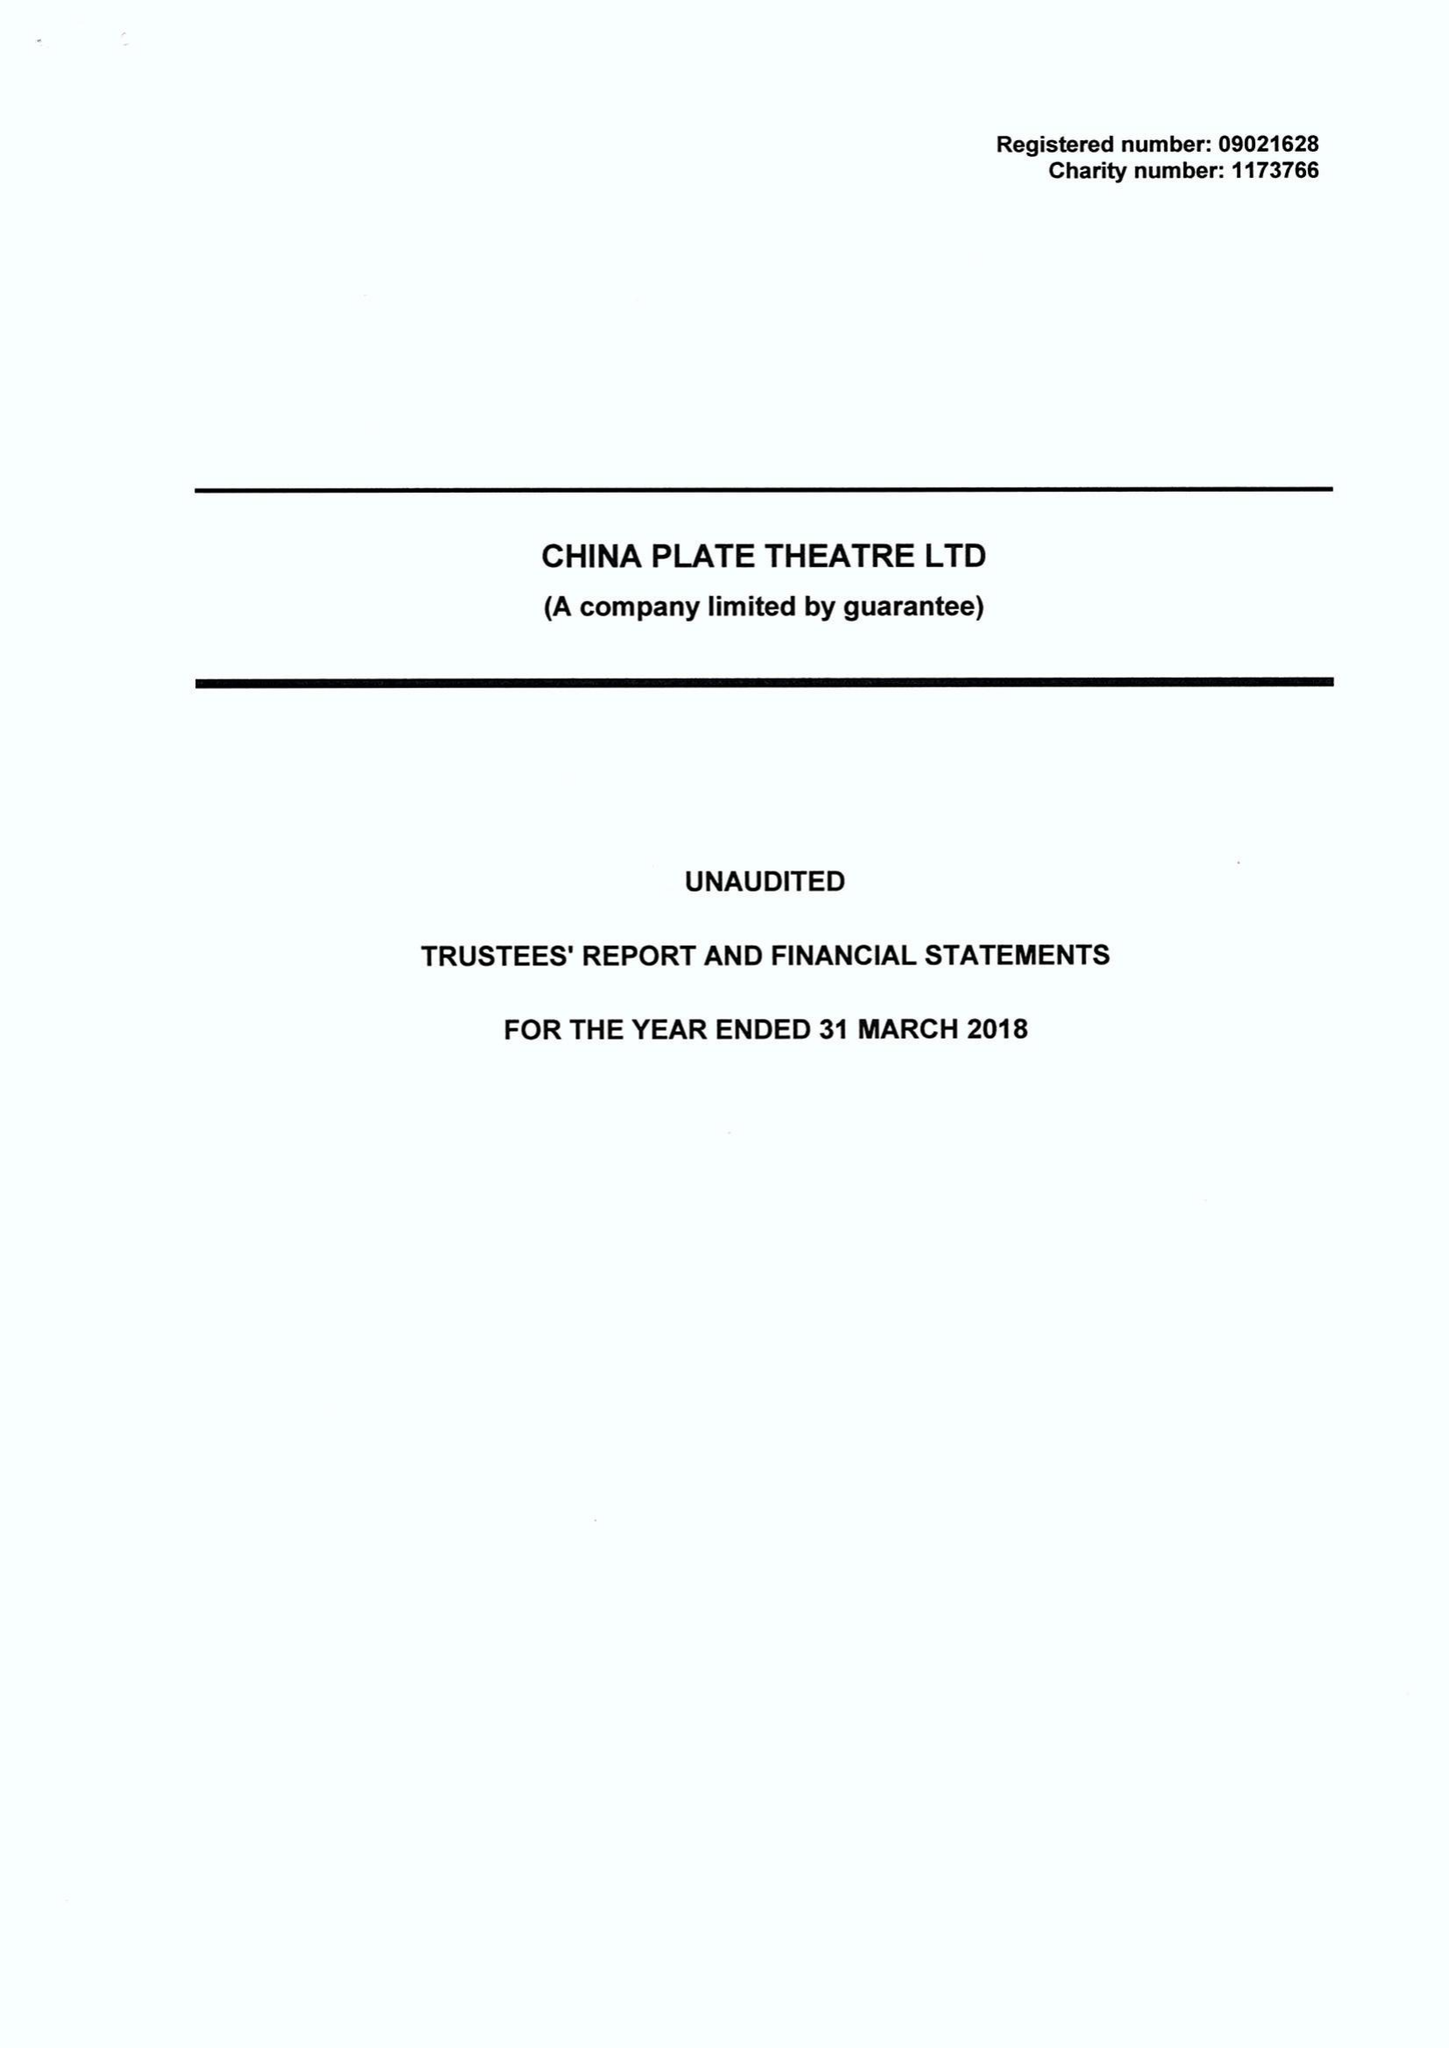What is the value for the address__postcode?
Answer the question using a single word or phrase. B5 5SE 